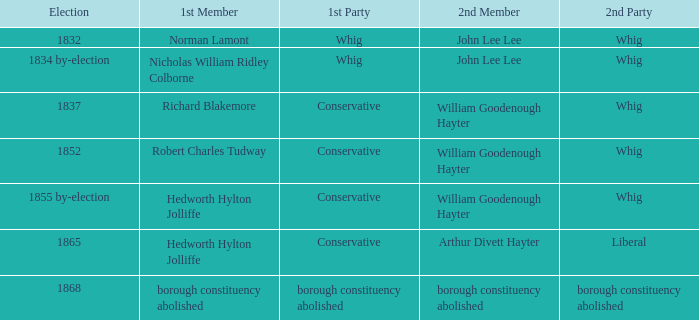What's the 2nd party of 2nd member william goodenough hayter when the 1st member is hedworth hylton jolliffe? Whig. 